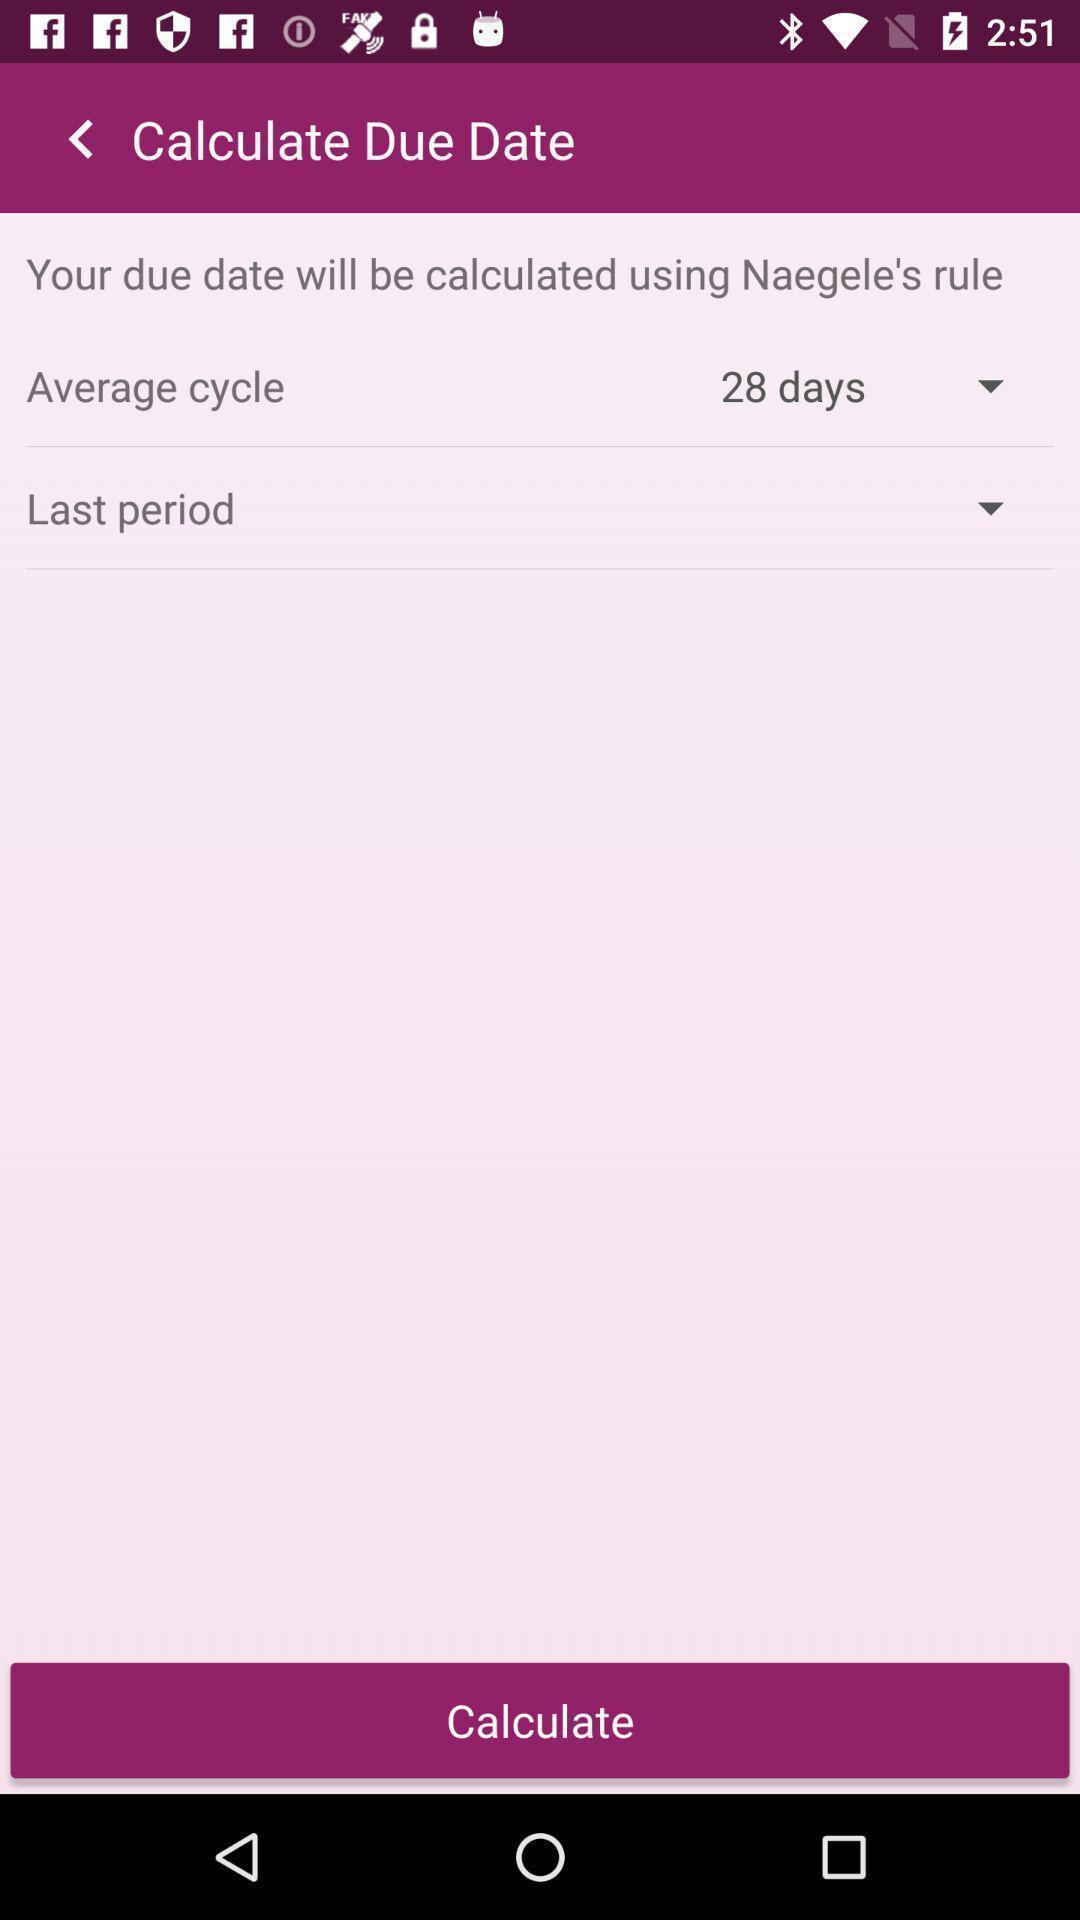What is the overall content of this screenshot? Page to calculate in the pregnancy tracking app. 